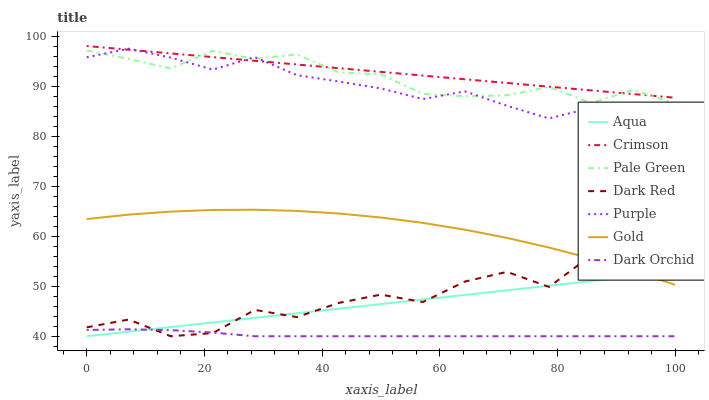Does Dark Orchid have the minimum area under the curve?
Answer yes or no. Yes. Does Crimson have the maximum area under the curve?
Answer yes or no. Yes. Does Purple have the minimum area under the curve?
Answer yes or no. No. Does Purple have the maximum area under the curve?
Answer yes or no. No. Is Aqua the smoothest?
Answer yes or no. Yes. Is Dark Red the roughest?
Answer yes or no. Yes. Is Purple the smoothest?
Answer yes or no. No. Is Purple the roughest?
Answer yes or no. No. Does Dark Red have the lowest value?
Answer yes or no. Yes. Does Purple have the lowest value?
Answer yes or no. No. Does Crimson have the highest value?
Answer yes or no. Yes. Does Purple have the highest value?
Answer yes or no. No. Is Dark Orchid less than Gold?
Answer yes or no. Yes. Is Pale Green greater than Aqua?
Answer yes or no. Yes. Does Crimson intersect Purple?
Answer yes or no. Yes. Is Crimson less than Purple?
Answer yes or no. No. Is Crimson greater than Purple?
Answer yes or no. No. Does Dark Orchid intersect Gold?
Answer yes or no. No. 